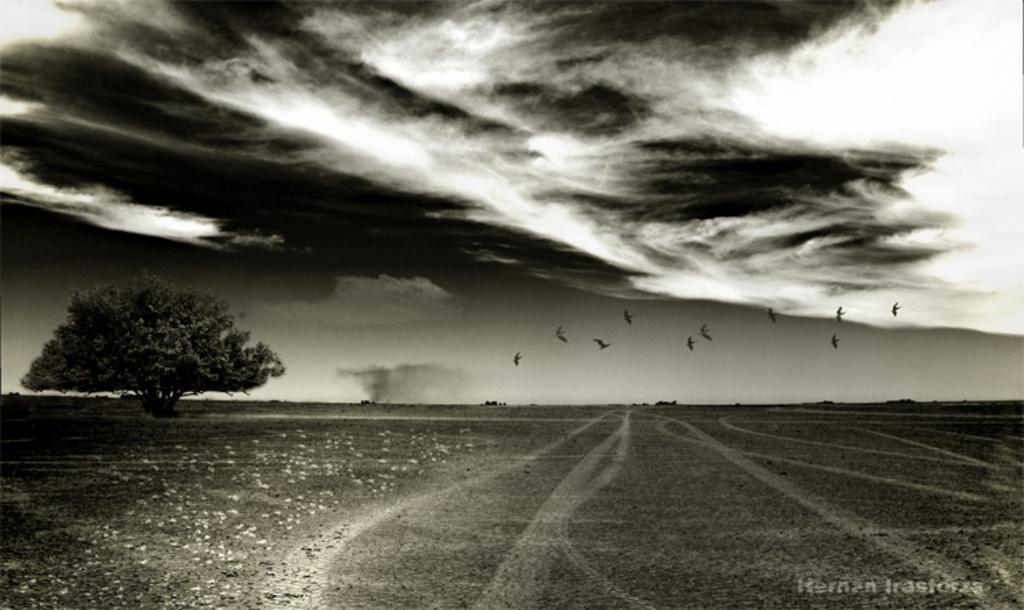What is the main setting of the image? There is an open ground in the image. Are there any plants or trees in the image? Yes, there is a tree in the image. What else can be seen in the sky besides clouds? There are birds in the air in the image. What is the color scheme of the image? The image is in black and white color. What type of corn is growing on the tree in the image? There is no corn present in the image, as it only features a tree and birds in the air. 